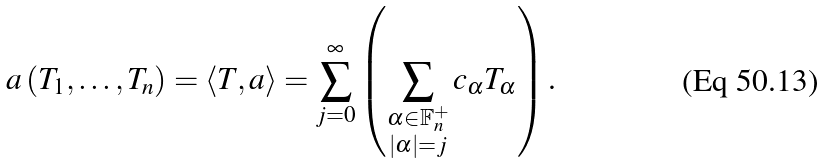Convert formula to latex. <formula><loc_0><loc_0><loc_500><loc_500>a \left ( T _ { 1 } , \dots , T _ { n } \right ) = \left \langle T , a \right \rangle = \sum _ { j = 0 } ^ { \infty } \left ( \sum _ { \substack { \alpha \in \mathbb { F } _ { n } ^ { + } \\ \left | \alpha \right | = j } } c _ { \alpha } T _ { \alpha } \right ) \text {.}</formula> 